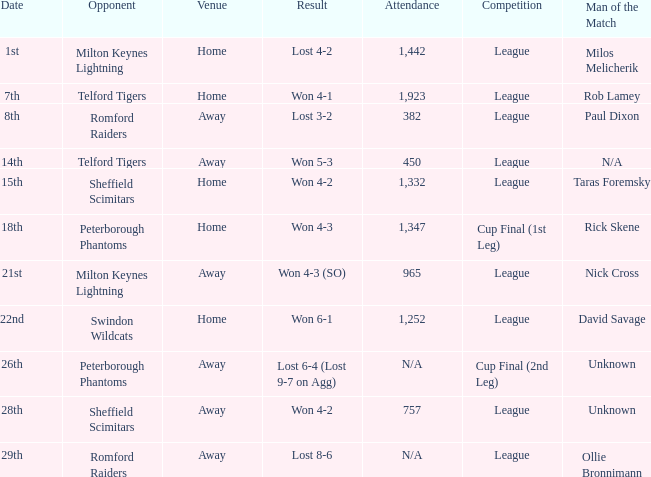Who earned the man of the match award in the away game versus milton keynes lightning? Nick Cross. 